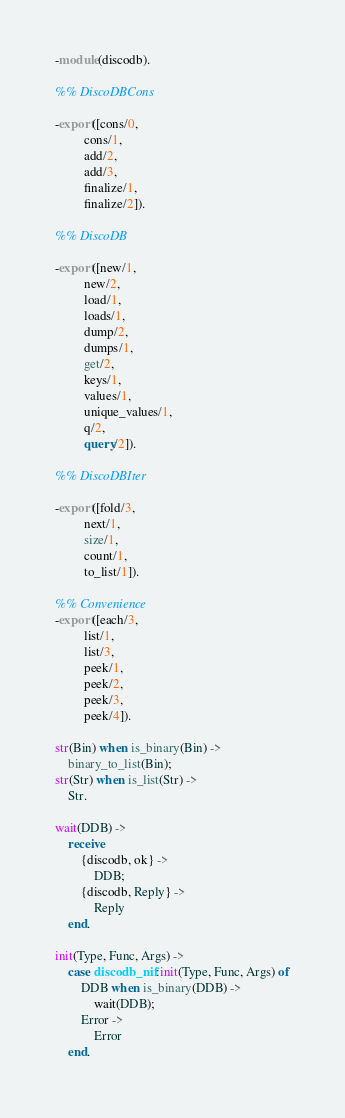Convert code to text. <code><loc_0><loc_0><loc_500><loc_500><_Erlang_>-module(discodb).

%% DiscoDBCons

-export([cons/0,
         cons/1,
         add/2,
         add/3,
         finalize/1,
         finalize/2]).

%% DiscoDB

-export([new/1,
         new/2,
         load/1,
         loads/1,
         dump/2,
         dumps/1,
         get/2,
         keys/1,
         values/1,
         unique_values/1,
         q/2,
         query/2]).

%% DiscoDBIter

-export([fold/3,
         next/1,
         size/1,
         count/1,
         to_list/1]).

%% Convenience
-export([each/3,
         list/1,
         list/3,
         peek/1,
         peek/2,
         peek/3,
         peek/4]).

str(Bin) when is_binary(Bin) ->
    binary_to_list(Bin);
str(Str) when is_list(Str) ->
    Str.

wait(DDB) ->
    receive
        {discodb, ok} ->
            DDB;
        {discodb, Reply} ->
            Reply
    end.

init(Type, Func, Args) ->
    case discodb_nif:init(Type, Func, Args) of
        DDB when is_binary(DDB) ->
            wait(DDB);
        Error ->
            Error
    end.
</code> 